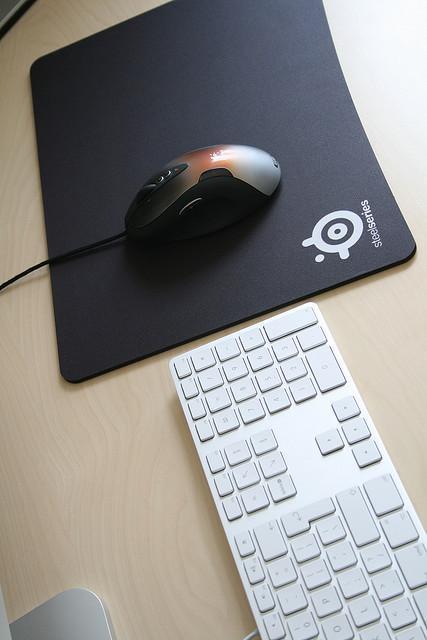How many mouse pads ar? there?
Give a very brief answer. 1. How many skateboards are there?
Give a very brief answer. 0. 